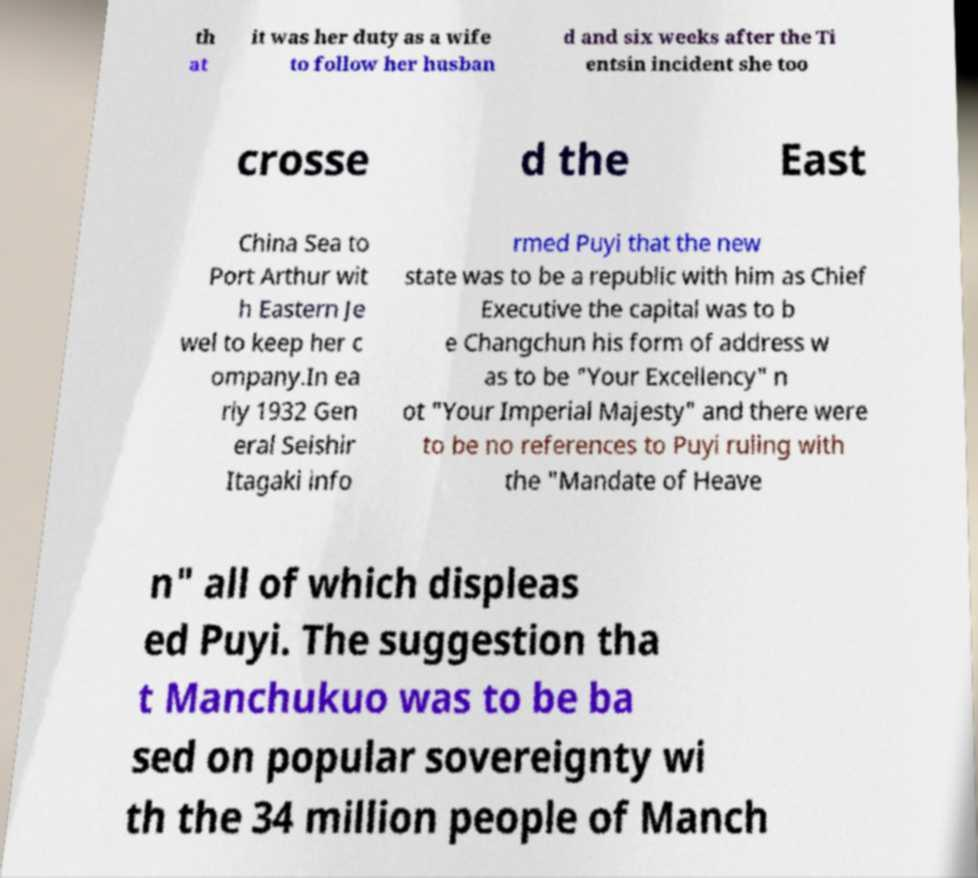What messages or text are displayed in this image? I need them in a readable, typed format. th at it was her duty as a wife to follow her husban d and six weeks after the Ti entsin incident she too crosse d the East China Sea to Port Arthur wit h Eastern Je wel to keep her c ompany.In ea rly 1932 Gen eral Seishir Itagaki info rmed Puyi that the new state was to be a republic with him as Chief Executive the capital was to b e Changchun his form of address w as to be "Your Excellency" n ot "Your Imperial Majesty" and there were to be no references to Puyi ruling with the "Mandate of Heave n" all of which displeas ed Puyi. The suggestion tha t Manchukuo was to be ba sed on popular sovereignty wi th the 34 million people of Manch 